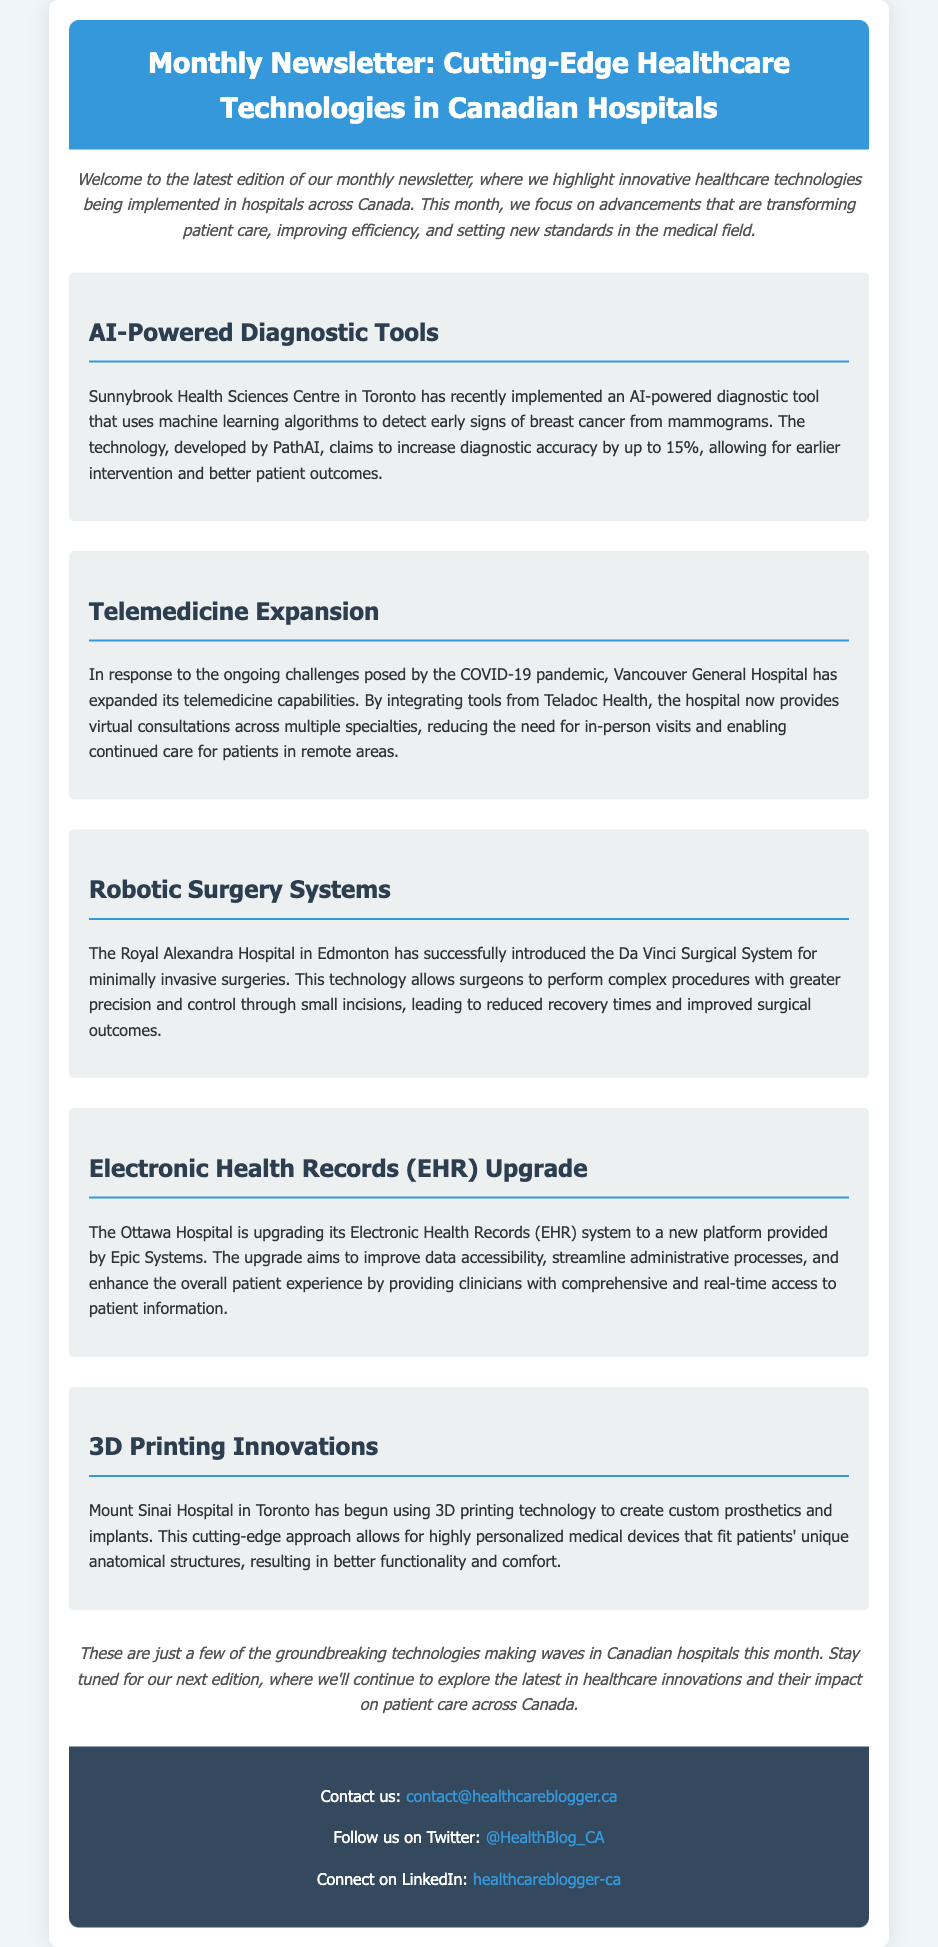What is the title of the newsletter? The title of the newsletter is mentioned in the header section of the document.
Answer: Monthly Newsletter: Cutting-Edge Healthcare Technologies in Canadian Hospitals Which hospital implemented an AI-powered diagnostic tool? The document lists Sunnybrook Health Sciences Centre in Toronto as the hospital implementing the AI tool.
Answer: Sunnybrook Health Sciences Centre What technology is used for virtual consultations at Vancouver General Hospital? The technology mentioned for virtual consultations is provided by Teladoc Health.
Answer: Teladoc Health What system is being upgraded at the Ottawa Hospital? The document specifies that the Electronic Health Records (EHR) system is being upgraded.
Answer: Electronic Health Records (EHR) How many hospitals are highlighted in this newsletter? The newsletter highlights five hospitals, each associated with different technologies.
Answer: Five What type of surgery system was introduced at the Royal Alexandra Hospital? The document mentions the Da Vinci Surgical System for minimally invasive surgeries.
Answer: Da Vinci Surgical System What innovative technology is being used at Mount Sinai Hospital? The document states that Mount Sinai Hospital is using 3D printing technology.
Answer: 3D printing technology What is the purpose of the newsletter? The document outlines that the newsletter aims to highlight new healthcare technologies in Canadian hospitals.
Answer: Highlighting new healthcare technologies in Canadian hospitals 